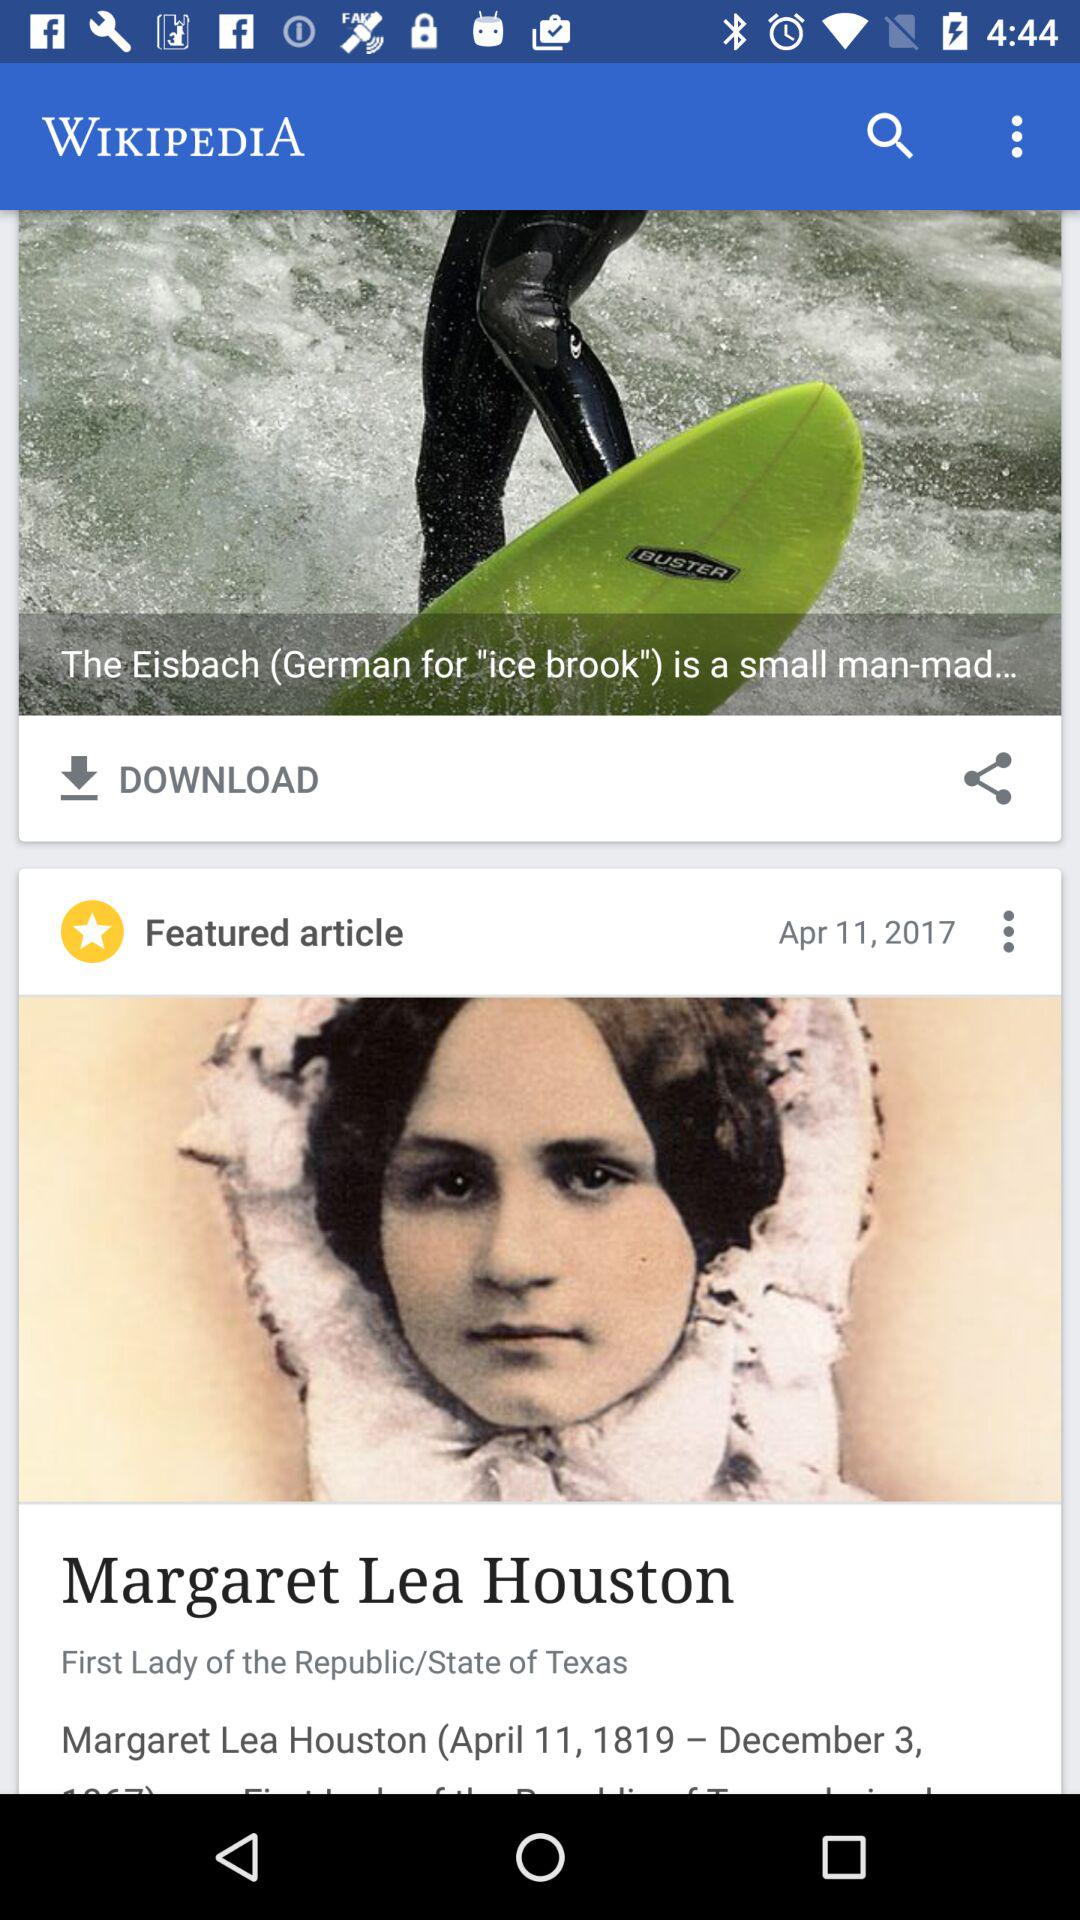On what date is the featured article updated? The featured article is updated on April 11, 2017. 